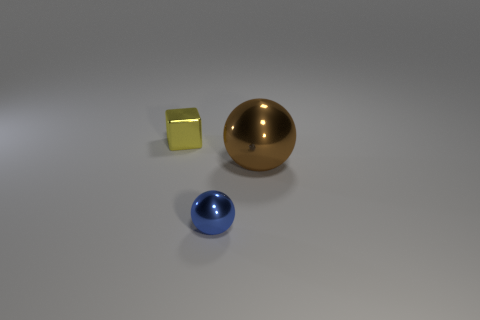What shape is the tiny thing right of the metal thing that is behind the ball to the right of the blue metal object?
Offer a terse response. Sphere. What material is the object that is both in front of the small yellow shiny block and behind the tiny blue object?
Offer a terse response. Metal. How many brown spheres have the same size as the block?
Your response must be concise. 0. How many metallic things are yellow things or large spheres?
Your answer should be very brief. 2. What is the tiny block made of?
Your answer should be compact. Metal. There is a yellow object; how many small yellow cubes are on the right side of it?
Offer a very short reply. 0. Is the material of the small object behind the small ball the same as the big ball?
Give a very brief answer. Yes. How many large objects have the same shape as the tiny blue object?
Keep it short and to the point. 1. What number of tiny things are brown balls or yellow things?
Your answer should be compact. 1. Does the tiny metal thing to the right of the shiny block have the same color as the small cube?
Provide a succinct answer. No. 